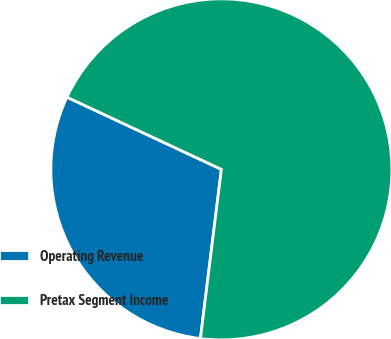<chart> <loc_0><loc_0><loc_500><loc_500><pie_chart><fcel>Operating Revenue<fcel>Pretax Segment Income<nl><fcel>30.0%<fcel>70.0%<nl></chart> 